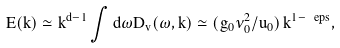<formula> <loc_0><loc_0><loc_500><loc_500>E ( k ) \simeq k ^ { d - 1 } \int d \omega D _ { v } ( \omega , k ) \simeq ( g _ { 0 } \nu _ { 0 } ^ { 2 } / u _ { 0 } ) \, k ^ { 1 - \ e p s } ,</formula> 